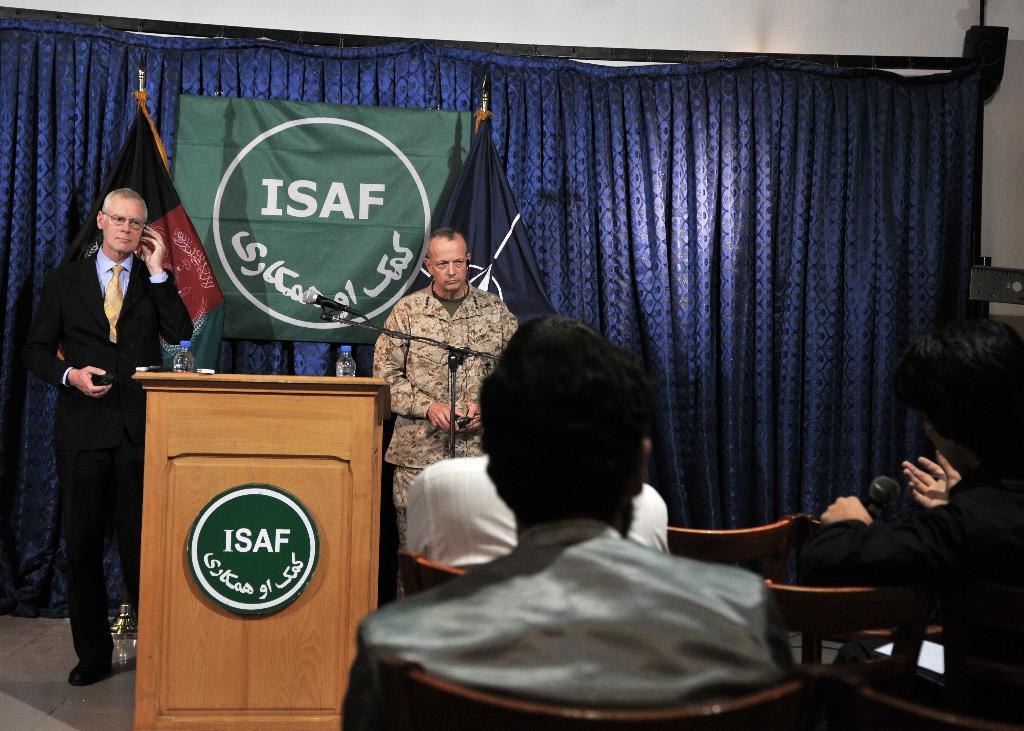<image>
Create a compact narrative representing the image presented. A podium and banner with a white circle on a green background and white letters ISAF, with two men standing between them. 